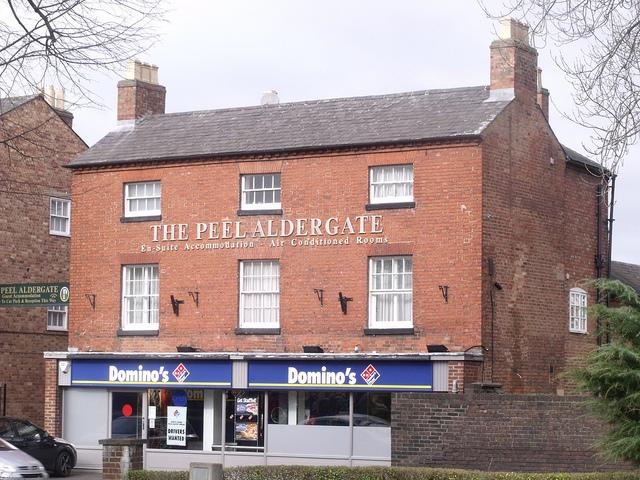What pizza place is on the main level?

Choices:
A) little caesars
B) pizza hut
C) papa john's
D) domino's domino's 